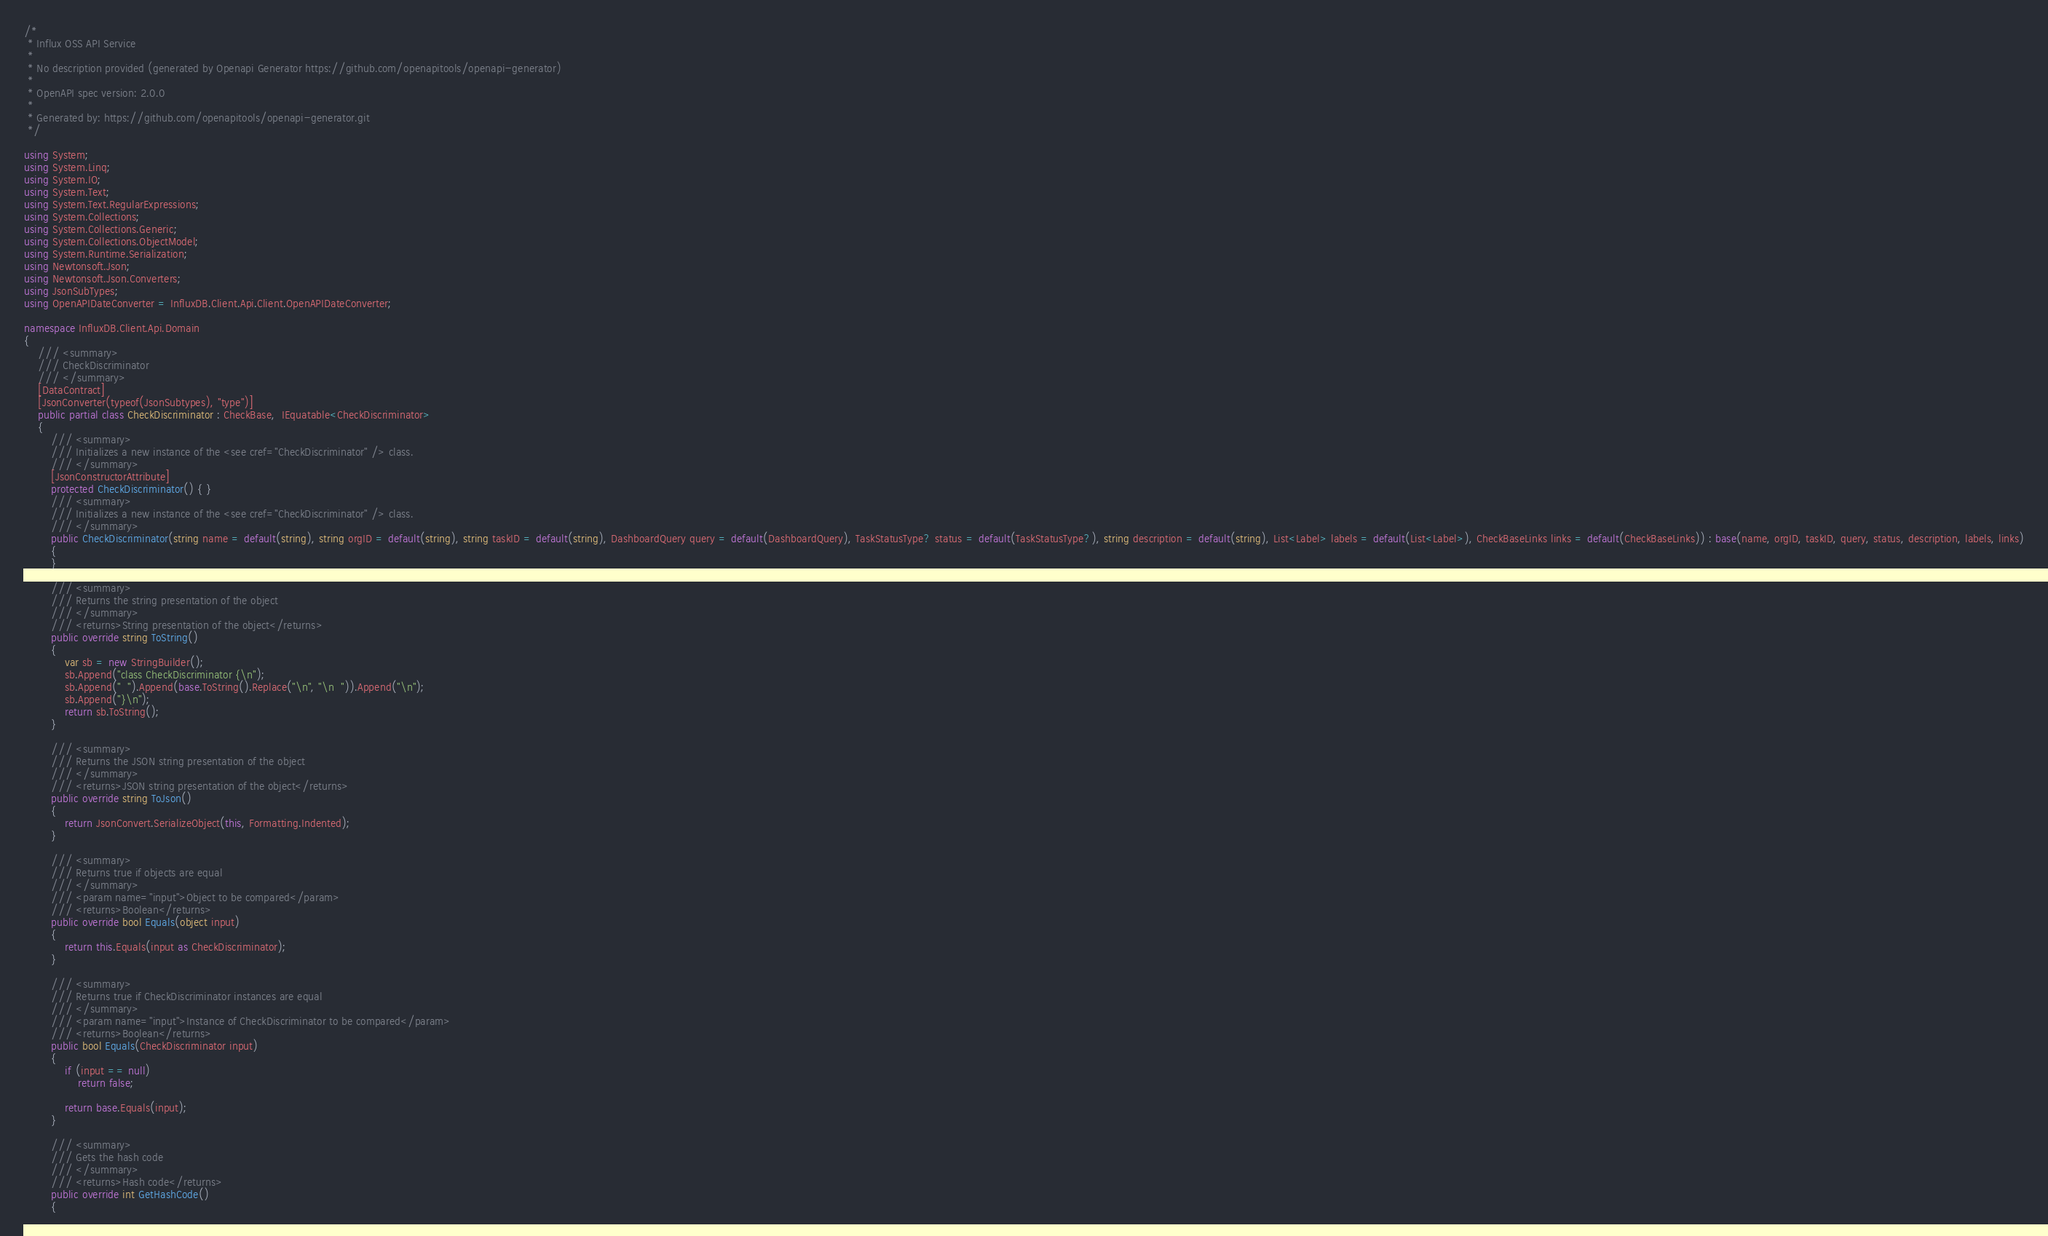<code> <loc_0><loc_0><loc_500><loc_500><_C#_>/* 
 * Influx OSS API Service
 *
 * No description provided (generated by Openapi Generator https://github.com/openapitools/openapi-generator)
 *
 * OpenAPI spec version: 2.0.0
 * 
 * Generated by: https://github.com/openapitools/openapi-generator.git
 */

using System;
using System.Linq;
using System.IO;
using System.Text;
using System.Text.RegularExpressions;
using System.Collections;
using System.Collections.Generic;
using System.Collections.ObjectModel;
using System.Runtime.Serialization;
using Newtonsoft.Json;
using Newtonsoft.Json.Converters;
using JsonSubTypes;
using OpenAPIDateConverter = InfluxDB.Client.Api.Client.OpenAPIDateConverter;

namespace InfluxDB.Client.Api.Domain
{
    /// <summary>
    /// CheckDiscriminator
    /// </summary>
    [DataContract]
    [JsonConverter(typeof(JsonSubtypes), "type")]
    public partial class CheckDiscriminator : CheckBase,  IEquatable<CheckDiscriminator>
    {
        /// <summary>
        /// Initializes a new instance of the <see cref="CheckDiscriminator" /> class.
        /// </summary>
        [JsonConstructorAttribute]
        protected CheckDiscriminator() { }
        /// <summary>
        /// Initializes a new instance of the <see cref="CheckDiscriminator" /> class.
        /// </summary>
        public CheckDiscriminator(string name = default(string), string orgID = default(string), string taskID = default(string), DashboardQuery query = default(DashboardQuery), TaskStatusType? status = default(TaskStatusType?), string description = default(string), List<Label> labels = default(List<Label>), CheckBaseLinks links = default(CheckBaseLinks)) : base(name, orgID, taskID, query, status, description, labels, links)
        {
        }

        /// <summary>
        /// Returns the string presentation of the object
        /// </summary>
        /// <returns>String presentation of the object</returns>
        public override string ToString()
        {
            var sb = new StringBuilder();
            sb.Append("class CheckDiscriminator {\n");
            sb.Append("  ").Append(base.ToString().Replace("\n", "\n  ")).Append("\n");
            sb.Append("}\n");
            return sb.ToString();
        }

        /// <summary>
        /// Returns the JSON string presentation of the object
        /// </summary>
        /// <returns>JSON string presentation of the object</returns>
        public override string ToJson()
        {
            return JsonConvert.SerializeObject(this, Formatting.Indented);
        }

        /// <summary>
        /// Returns true if objects are equal
        /// </summary>
        /// <param name="input">Object to be compared</param>
        /// <returns>Boolean</returns>
        public override bool Equals(object input)
        {
            return this.Equals(input as CheckDiscriminator);
        }

        /// <summary>
        /// Returns true if CheckDiscriminator instances are equal
        /// </summary>
        /// <param name="input">Instance of CheckDiscriminator to be compared</param>
        /// <returns>Boolean</returns>
        public bool Equals(CheckDiscriminator input)
        {
            if (input == null)
                return false;

            return base.Equals(input);
        }

        /// <summary>
        /// Gets the hash code
        /// </summary>
        /// <returns>Hash code</returns>
        public override int GetHashCode()
        {</code> 